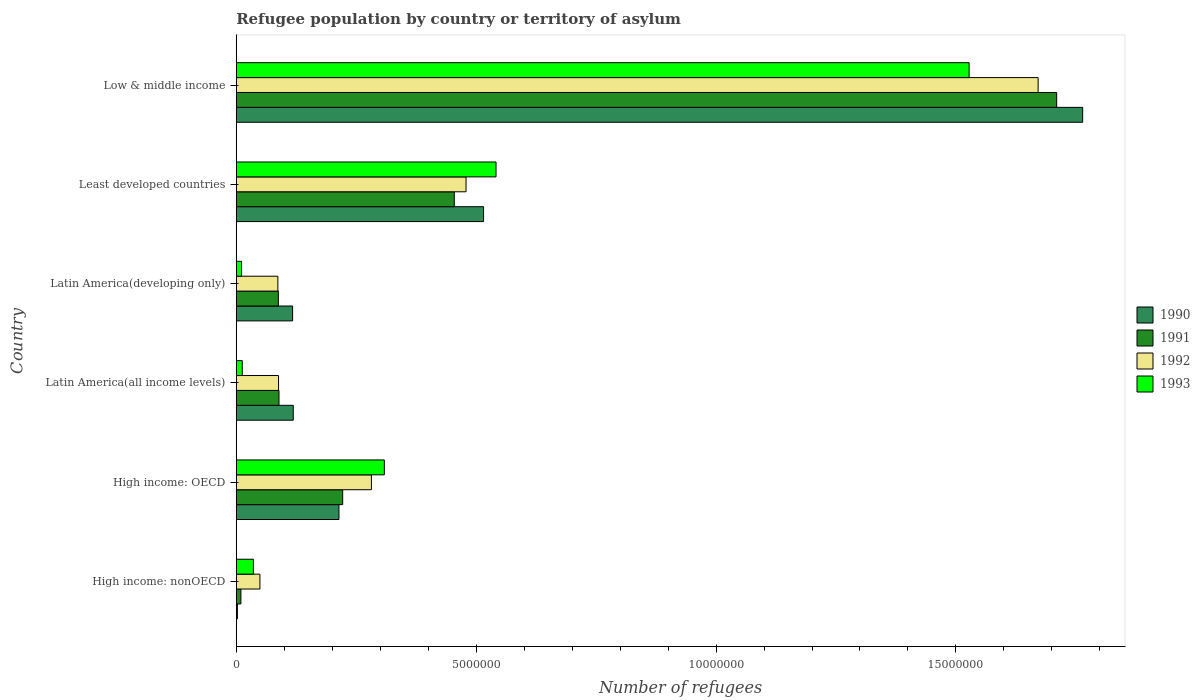Are the number of bars per tick equal to the number of legend labels?
Keep it short and to the point. Yes. Are the number of bars on each tick of the Y-axis equal?
Your answer should be compact. Yes. What is the label of the 3rd group of bars from the top?
Your response must be concise. Latin America(developing only). In how many cases, is the number of bars for a given country not equal to the number of legend labels?
Offer a very short reply. 0. What is the number of refugees in 1991 in High income: OECD?
Keep it short and to the point. 2.22e+06. Across all countries, what is the maximum number of refugees in 1993?
Your answer should be very brief. 1.53e+07. Across all countries, what is the minimum number of refugees in 1993?
Offer a very short reply. 1.11e+05. In which country was the number of refugees in 1992 minimum?
Provide a succinct answer. High income: nonOECD. What is the total number of refugees in 1993 in the graph?
Keep it short and to the point. 2.44e+07. What is the difference between the number of refugees in 1992 in High income: nonOECD and that in Latin America(developing only)?
Your answer should be compact. -3.74e+05. What is the difference between the number of refugees in 1993 in Least developed countries and the number of refugees in 1991 in High income: nonOECD?
Make the answer very short. 5.32e+06. What is the average number of refugees in 1990 per country?
Keep it short and to the point. 4.55e+06. What is the difference between the number of refugees in 1992 and number of refugees in 1991 in Least developed countries?
Your answer should be very brief. 2.45e+05. In how many countries, is the number of refugees in 1990 greater than 9000000 ?
Give a very brief answer. 1. What is the ratio of the number of refugees in 1990 in Latin America(all income levels) to that in Low & middle income?
Ensure brevity in your answer.  0.07. Is the number of refugees in 1991 in Latin America(all income levels) less than that in Latin America(developing only)?
Offer a terse response. No. What is the difference between the highest and the second highest number of refugees in 1990?
Make the answer very short. 1.25e+07. What is the difference between the highest and the lowest number of refugees in 1993?
Offer a very short reply. 1.52e+07. Is the sum of the number of refugees in 1992 in Latin America(all income levels) and Latin America(developing only) greater than the maximum number of refugees in 1993 across all countries?
Provide a short and direct response. No. What does the 1st bar from the top in High income: OECD represents?
Give a very brief answer. 1993. What does the 3rd bar from the bottom in High income: nonOECD represents?
Provide a succinct answer. 1992. Are all the bars in the graph horizontal?
Provide a succinct answer. Yes. How many countries are there in the graph?
Ensure brevity in your answer.  6. What is the difference between two consecutive major ticks on the X-axis?
Ensure brevity in your answer.  5.00e+06. Are the values on the major ticks of X-axis written in scientific E-notation?
Keep it short and to the point. No. Where does the legend appear in the graph?
Keep it short and to the point. Center right. What is the title of the graph?
Give a very brief answer. Refugee population by country or territory of asylum. Does "1980" appear as one of the legend labels in the graph?
Offer a very short reply. No. What is the label or title of the X-axis?
Provide a short and direct response. Number of refugees. What is the Number of refugees of 1990 in High income: nonOECD?
Your answer should be very brief. 2.39e+04. What is the Number of refugees of 1991 in High income: nonOECD?
Your answer should be very brief. 9.69e+04. What is the Number of refugees in 1992 in High income: nonOECD?
Your answer should be very brief. 4.93e+05. What is the Number of refugees in 1993 in High income: nonOECD?
Your response must be concise. 3.58e+05. What is the Number of refugees of 1990 in High income: OECD?
Your response must be concise. 2.14e+06. What is the Number of refugees in 1991 in High income: OECD?
Offer a terse response. 2.22e+06. What is the Number of refugees in 1992 in High income: OECD?
Offer a terse response. 2.82e+06. What is the Number of refugees of 1993 in High income: OECD?
Keep it short and to the point. 3.09e+06. What is the Number of refugees of 1990 in Latin America(all income levels)?
Offer a terse response. 1.19e+06. What is the Number of refugees in 1991 in Latin America(all income levels)?
Your response must be concise. 8.91e+05. What is the Number of refugees in 1992 in Latin America(all income levels)?
Give a very brief answer. 8.82e+05. What is the Number of refugees in 1993 in Latin America(all income levels)?
Provide a succinct answer. 1.25e+05. What is the Number of refugees of 1990 in Latin America(developing only)?
Make the answer very short. 1.17e+06. What is the Number of refugees in 1991 in Latin America(developing only)?
Provide a short and direct response. 8.78e+05. What is the Number of refugees of 1992 in Latin America(developing only)?
Your answer should be compact. 8.67e+05. What is the Number of refugees of 1993 in Latin America(developing only)?
Offer a terse response. 1.11e+05. What is the Number of refugees in 1990 in Least developed countries?
Your answer should be very brief. 5.15e+06. What is the Number of refugees in 1991 in Least developed countries?
Make the answer very short. 4.54e+06. What is the Number of refugees in 1992 in Least developed countries?
Give a very brief answer. 4.79e+06. What is the Number of refugees in 1993 in Least developed countries?
Give a very brief answer. 5.41e+06. What is the Number of refugees of 1990 in Low & middle income?
Provide a succinct answer. 1.76e+07. What is the Number of refugees of 1991 in Low & middle income?
Keep it short and to the point. 1.71e+07. What is the Number of refugees of 1992 in Low & middle income?
Your response must be concise. 1.67e+07. What is the Number of refugees in 1993 in Low & middle income?
Offer a terse response. 1.53e+07. Across all countries, what is the maximum Number of refugees in 1990?
Ensure brevity in your answer.  1.76e+07. Across all countries, what is the maximum Number of refugees of 1991?
Provide a succinct answer. 1.71e+07. Across all countries, what is the maximum Number of refugees in 1992?
Provide a short and direct response. 1.67e+07. Across all countries, what is the maximum Number of refugees in 1993?
Provide a short and direct response. 1.53e+07. Across all countries, what is the minimum Number of refugees in 1990?
Provide a short and direct response. 2.39e+04. Across all countries, what is the minimum Number of refugees of 1991?
Give a very brief answer. 9.69e+04. Across all countries, what is the minimum Number of refugees of 1992?
Provide a succinct answer. 4.93e+05. Across all countries, what is the minimum Number of refugees of 1993?
Provide a succinct answer. 1.11e+05. What is the total Number of refugees in 1990 in the graph?
Provide a short and direct response. 2.73e+07. What is the total Number of refugees in 1991 in the graph?
Offer a terse response. 2.57e+07. What is the total Number of refugees of 1992 in the graph?
Your answer should be compact. 2.66e+07. What is the total Number of refugees of 1993 in the graph?
Offer a terse response. 2.44e+07. What is the difference between the Number of refugees of 1990 in High income: nonOECD and that in High income: OECD?
Keep it short and to the point. -2.12e+06. What is the difference between the Number of refugees of 1991 in High income: nonOECD and that in High income: OECD?
Your response must be concise. -2.12e+06. What is the difference between the Number of refugees in 1992 in High income: nonOECD and that in High income: OECD?
Provide a succinct answer. -2.32e+06. What is the difference between the Number of refugees in 1993 in High income: nonOECD and that in High income: OECD?
Offer a terse response. -2.73e+06. What is the difference between the Number of refugees of 1990 in High income: nonOECD and that in Latin America(all income levels)?
Offer a very short reply. -1.16e+06. What is the difference between the Number of refugees of 1991 in High income: nonOECD and that in Latin America(all income levels)?
Ensure brevity in your answer.  -7.94e+05. What is the difference between the Number of refugees of 1992 in High income: nonOECD and that in Latin America(all income levels)?
Offer a very short reply. -3.88e+05. What is the difference between the Number of refugees of 1993 in High income: nonOECD and that in Latin America(all income levels)?
Your answer should be very brief. 2.33e+05. What is the difference between the Number of refugees in 1990 in High income: nonOECD and that in Latin America(developing only)?
Your response must be concise. -1.15e+06. What is the difference between the Number of refugees in 1991 in High income: nonOECD and that in Latin America(developing only)?
Keep it short and to the point. -7.81e+05. What is the difference between the Number of refugees of 1992 in High income: nonOECD and that in Latin America(developing only)?
Give a very brief answer. -3.74e+05. What is the difference between the Number of refugees in 1993 in High income: nonOECD and that in Latin America(developing only)?
Offer a terse response. 2.47e+05. What is the difference between the Number of refugees in 1990 in High income: nonOECD and that in Least developed countries?
Offer a terse response. -5.13e+06. What is the difference between the Number of refugees of 1991 in High income: nonOECD and that in Least developed countries?
Your response must be concise. -4.45e+06. What is the difference between the Number of refugees of 1992 in High income: nonOECD and that in Least developed countries?
Ensure brevity in your answer.  -4.30e+06. What is the difference between the Number of refugees of 1993 in High income: nonOECD and that in Least developed countries?
Your answer should be very brief. -5.06e+06. What is the difference between the Number of refugees in 1990 in High income: nonOECD and that in Low & middle income?
Ensure brevity in your answer.  -1.76e+07. What is the difference between the Number of refugees of 1991 in High income: nonOECD and that in Low & middle income?
Your answer should be compact. -1.70e+07. What is the difference between the Number of refugees in 1992 in High income: nonOECD and that in Low & middle income?
Provide a short and direct response. -1.62e+07. What is the difference between the Number of refugees of 1993 in High income: nonOECD and that in Low & middle income?
Offer a very short reply. -1.49e+07. What is the difference between the Number of refugees in 1990 in High income: OECD and that in Latin America(all income levels)?
Provide a short and direct response. 9.52e+05. What is the difference between the Number of refugees in 1991 in High income: OECD and that in Latin America(all income levels)?
Give a very brief answer. 1.33e+06. What is the difference between the Number of refugees of 1992 in High income: OECD and that in Latin America(all income levels)?
Your answer should be very brief. 1.94e+06. What is the difference between the Number of refugees in 1993 in High income: OECD and that in Latin America(all income levels)?
Offer a terse response. 2.96e+06. What is the difference between the Number of refugees of 1990 in High income: OECD and that in Latin America(developing only)?
Provide a succinct answer. 9.66e+05. What is the difference between the Number of refugees of 1991 in High income: OECD and that in Latin America(developing only)?
Give a very brief answer. 1.34e+06. What is the difference between the Number of refugees in 1992 in High income: OECD and that in Latin America(developing only)?
Offer a terse response. 1.95e+06. What is the difference between the Number of refugees of 1993 in High income: OECD and that in Latin America(developing only)?
Provide a short and direct response. 2.98e+06. What is the difference between the Number of refugees in 1990 in High income: OECD and that in Least developed countries?
Your response must be concise. -3.01e+06. What is the difference between the Number of refugees in 1991 in High income: OECD and that in Least developed countries?
Make the answer very short. -2.33e+06. What is the difference between the Number of refugees in 1992 in High income: OECD and that in Least developed countries?
Your response must be concise. -1.97e+06. What is the difference between the Number of refugees in 1993 in High income: OECD and that in Least developed countries?
Provide a short and direct response. -2.33e+06. What is the difference between the Number of refugees in 1990 in High income: OECD and that in Low & middle income?
Offer a very short reply. -1.55e+07. What is the difference between the Number of refugees of 1991 in High income: OECD and that in Low & middle income?
Ensure brevity in your answer.  -1.49e+07. What is the difference between the Number of refugees of 1992 in High income: OECD and that in Low & middle income?
Provide a succinct answer. -1.39e+07. What is the difference between the Number of refugees in 1993 in High income: OECD and that in Low & middle income?
Ensure brevity in your answer.  -1.22e+07. What is the difference between the Number of refugees in 1990 in Latin America(all income levels) and that in Latin America(developing only)?
Your answer should be very brief. 1.36e+04. What is the difference between the Number of refugees of 1991 in Latin America(all income levels) and that in Latin America(developing only)?
Give a very brief answer. 1.34e+04. What is the difference between the Number of refugees of 1992 in Latin America(all income levels) and that in Latin America(developing only)?
Provide a succinct answer. 1.41e+04. What is the difference between the Number of refugees in 1993 in Latin America(all income levels) and that in Latin America(developing only)?
Provide a short and direct response. 1.43e+04. What is the difference between the Number of refugees in 1990 in Latin America(all income levels) and that in Least developed countries?
Offer a very short reply. -3.97e+06. What is the difference between the Number of refugees of 1991 in Latin America(all income levels) and that in Least developed countries?
Provide a short and direct response. -3.65e+06. What is the difference between the Number of refugees in 1992 in Latin America(all income levels) and that in Least developed countries?
Make the answer very short. -3.91e+06. What is the difference between the Number of refugees of 1993 in Latin America(all income levels) and that in Least developed countries?
Provide a succinct answer. -5.29e+06. What is the difference between the Number of refugees in 1990 in Latin America(all income levels) and that in Low & middle income?
Provide a short and direct response. -1.65e+07. What is the difference between the Number of refugees in 1991 in Latin America(all income levels) and that in Low & middle income?
Provide a succinct answer. -1.62e+07. What is the difference between the Number of refugees in 1992 in Latin America(all income levels) and that in Low & middle income?
Provide a short and direct response. -1.58e+07. What is the difference between the Number of refugees of 1993 in Latin America(all income levels) and that in Low & middle income?
Offer a terse response. -1.51e+07. What is the difference between the Number of refugees in 1990 in Latin America(developing only) and that in Least developed countries?
Make the answer very short. -3.98e+06. What is the difference between the Number of refugees of 1991 in Latin America(developing only) and that in Least developed countries?
Ensure brevity in your answer.  -3.67e+06. What is the difference between the Number of refugees of 1992 in Latin America(developing only) and that in Least developed countries?
Provide a succinct answer. -3.92e+06. What is the difference between the Number of refugees in 1993 in Latin America(developing only) and that in Least developed countries?
Your response must be concise. -5.30e+06. What is the difference between the Number of refugees in 1990 in Latin America(developing only) and that in Low & middle income?
Your answer should be very brief. -1.65e+07. What is the difference between the Number of refugees of 1991 in Latin America(developing only) and that in Low & middle income?
Your response must be concise. -1.62e+07. What is the difference between the Number of refugees of 1992 in Latin America(developing only) and that in Low & middle income?
Your response must be concise. -1.58e+07. What is the difference between the Number of refugees in 1993 in Latin America(developing only) and that in Low & middle income?
Offer a very short reply. -1.52e+07. What is the difference between the Number of refugees in 1990 in Least developed countries and that in Low & middle income?
Your answer should be very brief. -1.25e+07. What is the difference between the Number of refugees of 1991 in Least developed countries and that in Low & middle income?
Ensure brevity in your answer.  -1.26e+07. What is the difference between the Number of refugees of 1992 in Least developed countries and that in Low & middle income?
Your answer should be very brief. -1.19e+07. What is the difference between the Number of refugees in 1993 in Least developed countries and that in Low & middle income?
Provide a succinct answer. -9.86e+06. What is the difference between the Number of refugees in 1990 in High income: nonOECD and the Number of refugees in 1991 in High income: OECD?
Your response must be concise. -2.19e+06. What is the difference between the Number of refugees of 1990 in High income: nonOECD and the Number of refugees of 1992 in High income: OECD?
Provide a short and direct response. -2.79e+06. What is the difference between the Number of refugees in 1990 in High income: nonOECD and the Number of refugees in 1993 in High income: OECD?
Provide a succinct answer. -3.06e+06. What is the difference between the Number of refugees in 1991 in High income: nonOECD and the Number of refugees in 1992 in High income: OECD?
Give a very brief answer. -2.72e+06. What is the difference between the Number of refugees in 1991 in High income: nonOECD and the Number of refugees in 1993 in High income: OECD?
Ensure brevity in your answer.  -2.99e+06. What is the difference between the Number of refugees in 1992 in High income: nonOECD and the Number of refugees in 1993 in High income: OECD?
Your answer should be very brief. -2.59e+06. What is the difference between the Number of refugees of 1990 in High income: nonOECD and the Number of refugees of 1991 in Latin America(all income levels)?
Provide a succinct answer. -8.67e+05. What is the difference between the Number of refugees in 1990 in High income: nonOECD and the Number of refugees in 1992 in Latin America(all income levels)?
Offer a very short reply. -8.58e+05. What is the difference between the Number of refugees of 1990 in High income: nonOECD and the Number of refugees of 1993 in Latin America(all income levels)?
Make the answer very short. -1.01e+05. What is the difference between the Number of refugees of 1991 in High income: nonOECD and the Number of refugees of 1992 in Latin America(all income levels)?
Provide a short and direct response. -7.85e+05. What is the difference between the Number of refugees of 1991 in High income: nonOECD and the Number of refugees of 1993 in Latin America(all income levels)?
Provide a succinct answer. -2.83e+04. What is the difference between the Number of refugees of 1992 in High income: nonOECD and the Number of refugees of 1993 in Latin America(all income levels)?
Offer a terse response. 3.68e+05. What is the difference between the Number of refugees in 1990 in High income: nonOECD and the Number of refugees in 1991 in Latin America(developing only)?
Make the answer very short. -8.54e+05. What is the difference between the Number of refugees of 1990 in High income: nonOECD and the Number of refugees of 1992 in Latin America(developing only)?
Your answer should be very brief. -8.44e+05. What is the difference between the Number of refugees in 1990 in High income: nonOECD and the Number of refugees in 1993 in Latin America(developing only)?
Offer a very short reply. -8.71e+04. What is the difference between the Number of refugees in 1991 in High income: nonOECD and the Number of refugees in 1992 in Latin America(developing only)?
Keep it short and to the point. -7.70e+05. What is the difference between the Number of refugees in 1991 in High income: nonOECD and the Number of refugees in 1993 in Latin America(developing only)?
Your answer should be compact. -1.41e+04. What is the difference between the Number of refugees in 1992 in High income: nonOECD and the Number of refugees in 1993 in Latin America(developing only)?
Give a very brief answer. 3.82e+05. What is the difference between the Number of refugees of 1990 in High income: nonOECD and the Number of refugees of 1991 in Least developed countries?
Offer a very short reply. -4.52e+06. What is the difference between the Number of refugees of 1990 in High income: nonOECD and the Number of refugees of 1992 in Least developed countries?
Your response must be concise. -4.77e+06. What is the difference between the Number of refugees of 1990 in High income: nonOECD and the Number of refugees of 1993 in Least developed countries?
Your answer should be very brief. -5.39e+06. What is the difference between the Number of refugees of 1991 in High income: nonOECD and the Number of refugees of 1992 in Least developed countries?
Give a very brief answer. -4.69e+06. What is the difference between the Number of refugees of 1991 in High income: nonOECD and the Number of refugees of 1993 in Least developed countries?
Offer a very short reply. -5.32e+06. What is the difference between the Number of refugees in 1992 in High income: nonOECD and the Number of refugees in 1993 in Least developed countries?
Give a very brief answer. -4.92e+06. What is the difference between the Number of refugees of 1990 in High income: nonOECD and the Number of refugees of 1991 in Low & middle income?
Provide a succinct answer. -1.71e+07. What is the difference between the Number of refugees of 1990 in High income: nonOECD and the Number of refugees of 1992 in Low & middle income?
Provide a succinct answer. -1.67e+07. What is the difference between the Number of refugees in 1990 in High income: nonOECD and the Number of refugees in 1993 in Low & middle income?
Ensure brevity in your answer.  -1.53e+07. What is the difference between the Number of refugees in 1991 in High income: nonOECD and the Number of refugees in 1992 in Low & middle income?
Your response must be concise. -1.66e+07. What is the difference between the Number of refugees of 1991 in High income: nonOECD and the Number of refugees of 1993 in Low & middle income?
Your answer should be very brief. -1.52e+07. What is the difference between the Number of refugees of 1992 in High income: nonOECD and the Number of refugees of 1993 in Low & middle income?
Give a very brief answer. -1.48e+07. What is the difference between the Number of refugees of 1990 in High income: OECD and the Number of refugees of 1991 in Latin America(all income levels)?
Ensure brevity in your answer.  1.25e+06. What is the difference between the Number of refugees in 1990 in High income: OECD and the Number of refugees in 1992 in Latin America(all income levels)?
Provide a short and direct response. 1.26e+06. What is the difference between the Number of refugees in 1990 in High income: OECD and the Number of refugees in 1993 in Latin America(all income levels)?
Your response must be concise. 2.02e+06. What is the difference between the Number of refugees of 1991 in High income: OECD and the Number of refugees of 1992 in Latin America(all income levels)?
Your answer should be very brief. 1.34e+06. What is the difference between the Number of refugees of 1991 in High income: OECD and the Number of refugees of 1993 in Latin America(all income levels)?
Your answer should be compact. 2.09e+06. What is the difference between the Number of refugees in 1992 in High income: OECD and the Number of refugees in 1993 in Latin America(all income levels)?
Ensure brevity in your answer.  2.69e+06. What is the difference between the Number of refugees in 1990 in High income: OECD and the Number of refugees in 1991 in Latin America(developing only)?
Offer a very short reply. 1.26e+06. What is the difference between the Number of refugees in 1990 in High income: OECD and the Number of refugees in 1992 in Latin America(developing only)?
Ensure brevity in your answer.  1.27e+06. What is the difference between the Number of refugees in 1990 in High income: OECD and the Number of refugees in 1993 in Latin America(developing only)?
Ensure brevity in your answer.  2.03e+06. What is the difference between the Number of refugees of 1991 in High income: OECD and the Number of refugees of 1992 in Latin America(developing only)?
Provide a short and direct response. 1.35e+06. What is the difference between the Number of refugees in 1991 in High income: OECD and the Number of refugees in 1993 in Latin America(developing only)?
Offer a terse response. 2.11e+06. What is the difference between the Number of refugees of 1992 in High income: OECD and the Number of refugees of 1993 in Latin America(developing only)?
Provide a short and direct response. 2.71e+06. What is the difference between the Number of refugees of 1990 in High income: OECD and the Number of refugees of 1991 in Least developed countries?
Offer a terse response. -2.40e+06. What is the difference between the Number of refugees of 1990 in High income: OECD and the Number of refugees of 1992 in Least developed countries?
Provide a short and direct response. -2.65e+06. What is the difference between the Number of refugees of 1990 in High income: OECD and the Number of refugees of 1993 in Least developed countries?
Your response must be concise. -3.27e+06. What is the difference between the Number of refugees of 1991 in High income: OECD and the Number of refugees of 1992 in Least developed countries?
Give a very brief answer. -2.57e+06. What is the difference between the Number of refugees of 1991 in High income: OECD and the Number of refugees of 1993 in Least developed countries?
Give a very brief answer. -3.20e+06. What is the difference between the Number of refugees in 1992 in High income: OECD and the Number of refugees in 1993 in Least developed countries?
Offer a very short reply. -2.60e+06. What is the difference between the Number of refugees of 1990 in High income: OECD and the Number of refugees of 1991 in Low & middle income?
Make the answer very short. -1.50e+07. What is the difference between the Number of refugees of 1990 in High income: OECD and the Number of refugees of 1992 in Low & middle income?
Offer a very short reply. -1.46e+07. What is the difference between the Number of refugees of 1990 in High income: OECD and the Number of refugees of 1993 in Low & middle income?
Offer a very short reply. -1.31e+07. What is the difference between the Number of refugees of 1991 in High income: OECD and the Number of refugees of 1992 in Low & middle income?
Provide a short and direct response. -1.45e+07. What is the difference between the Number of refugees of 1991 in High income: OECD and the Number of refugees of 1993 in Low & middle income?
Keep it short and to the point. -1.31e+07. What is the difference between the Number of refugees of 1992 in High income: OECD and the Number of refugees of 1993 in Low & middle income?
Provide a short and direct response. -1.25e+07. What is the difference between the Number of refugees in 1990 in Latin America(all income levels) and the Number of refugees in 1991 in Latin America(developing only)?
Ensure brevity in your answer.  3.11e+05. What is the difference between the Number of refugees in 1990 in Latin America(all income levels) and the Number of refugees in 1992 in Latin America(developing only)?
Ensure brevity in your answer.  3.21e+05. What is the difference between the Number of refugees of 1990 in Latin America(all income levels) and the Number of refugees of 1993 in Latin America(developing only)?
Offer a terse response. 1.08e+06. What is the difference between the Number of refugees of 1991 in Latin America(all income levels) and the Number of refugees of 1992 in Latin America(developing only)?
Provide a succinct answer. 2.35e+04. What is the difference between the Number of refugees in 1991 in Latin America(all income levels) and the Number of refugees in 1993 in Latin America(developing only)?
Provide a short and direct response. 7.80e+05. What is the difference between the Number of refugees of 1992 in Latin America(all income levels) and the Number of refugees of 1993 in Latin America(developing only)?
Provide a succinct answer. 7.71e+05. What is the difference between the Number of refugees in 1990 in Latin America(all income levels) and the Number of refugees in 1991 in Least developed countries?
Make the answer very short. -3.36e+06. What is the difference between the Number of refugees in 1990 in Latin America(all income levels) and the Number of refugees in 1992 in Least developed countries?
Ensure brevity in your answer.  -3.60e+06. What is the difference between the Number of refugees in 1990 in Latin America(all income levels) and the Number of refugees in 1993 in Least developed countries?
Offer a very short reply. -4.23e+06. What is the difference between the Number of refugees in 1991 in Latin America(all income levels) and the Number of refugees in 1992 in Least developed countries?
Make the answer very short. -3.90e+06. What is the difference between the Number of refugees in 1991 in Latin America(all income levels) and the Number of refugees in 1993 in Least developed countries?
Your response must be concise. -4.52e+06. What is the difference between the Number of refugees in 1992 in Latin America(all income levels) and the Number of refugees in 1993 in Least developed countries?
Your answer should be compact. -4.53e+06. What is the difference between the Number of refugees of 1990 in Latin America(all income levels) and the Number of refugees of 1991 in Low & middle income?
Your answer should be compact. -1.59e+07. What is the difference between the Number of refugees in 1990 in Latin America(all income levels) and the Number of refugees in 1992 in Low & middle income?
Ensure brevity in your answer.  -1.55e+07. What is the difference between the Number of refugees in 1990 in Latin America(all income levels) and the Number of refugees in 1993 in Low & middle income?
Give a very brief answer. -1.41e+07. What is the difference between the Number of refugees in 1991 in Latin America(all income levels) and the Number of refugees in 1992 in Low & middle income?
Your response must be concise. -1.58e+07. What is the difference between the Number of refugees of 1991 in Latin America(all income levels) and the Number of refugees of 1993 in Low & middle income?
Give a very brief answer. -1.44e+07. What is the difference between the Number of refugees of 1992 in Latin America(all income levels) and the Number of refugees of 1993 in Low & middle income?
Your answer should be compact. -1.44e+07. What is the difference between the Number of refugees of 1990 in Latin America(developing only) and the Number of refugees of 1991 in Least developed countries?
Offer a terse response. -3.37e+06. What is the difference between the Number of refugees in 1990 in Latin America(developing only) and the Number of refugees in 1992 in Least developed countries?
Provide a succinct answer. -3.61e+06. What is the difference between the Number of refugees of 1990 in Latin America(developing only) and the Number of refugees of 1993 in Least developed countries?
Offer a terse response. -4.24e+06. What is the difference between the Number of refugees in 1991 in Latin America(developing only) and the Number of refugees in 1992 in Least developed countries?
Your answer should be compact. -3.91e+06. What is the difference between the Number of refugees in 1991 in Latin America(developing only) and the Number of refugees in 1993 in Least developed countries?
Your answer should be compact. -4.54e+06. What is the difference between the Number of refugees in 1992 in Latin America(developing only) and the Number of refugees in 1993 in Least developed countries?
Ensure brevity in your answer.  -4.55e+06. What is the difference between the Number of refugees of 1990 in Latin America(developing only) and the Number of refugees of 1991 in Low & middle income?
Provide a succinct answer. -1.59e+07. What is the difference between the Number of refugees of 1990 in Latin America(developing only) and the Number of refugees of 1992 in Low & middle income?
Make the answer very short. -1.55e+07. What is the difference between the Number of refugees of 1990 in Latin America(developing only) and the Number of refugees of 1993 in Low & middle income?
Ensure brevity in your answer.  -1.41e+07. What is the difference between the Number of refugees of 1991 in Latin America(developing only) and the Number of refugees of 1992 in Low & middle income?
Provide a short and direct response. -1.58e+07. What is the difference between the Number of refugees in 1991 in Latin America(developing only) and the Number of refugees in 1993 in Low & middle income?
Provide a short and direct response. -1.44e+07. What is the difference between the Number of refugees in 1992 in Latin America(developing only) and the Number of refugees in 1993 in Low & middle income?
Offer a terse response. -1.44e+07. What is the difference between the Number of refugees in 1990 in Least developed countries and the Number of refugees in 1991 in Low & middle income?
Ensure brevity in your answer.  -1.19e+07. What is the difference between the Number of refugees of 1990 in Least developed countries and the Number of refugees of 1992 in Low & middle income?
Make the answer very short. -1.16e+07. What is the difference between the Number of refugees in 1990 in Least developed countries and the Number of refugees in 1993 in Low & middle income?
Your answer should be very brief. -1.01e+07. What is the difference between the Number of refugees of 1991 in Least developed countries and the Number of refugees of 1992 in Low & middle income?
Provide a short and direct response. -1.22e+07. What is the difference between the Number of refugees of 1991 in Least developed countries and the Number of refugees of 1993 in Low & middle income?
Provide a short and direct response. -1.07e+07. What is the difference between the Number of refugees in 1992 in Least developed countries and the Number of refugees in 1993 in Low & middle income?
Keep it short and to the point. -1.05e+07. What is the average Number of refugees in 1990 per country?
Your response must be concise. 4.55e+06. What is the average Number of refugees in 1991 per country?
Offer a terse response. 4.29e+06. What is the average Number of refugees of 1992 per country?
Your answer should be very brief. 4.43e+06. What is the average Number of refugees in 1993 per country?
Your answer should be compact. 4.06e+06. What is the difference between the Number of refugees in 1990 and Number of refugees in 1991 in High income: nonOECD?
Give a very brief answer. -7.30e+04. What is the difference between the Number of refugees of 1990 and Number of refugees of 1992 in High income: nonOECD?
Keep it short and to the point. -4.69e+05. What is the difference between the Number of refugees of 1990 and Number of refugees of 1993 in High income: nonOECD?
Offer a terse response. -3.34e+05. What is the difference between the Number of refugees in 1991 and Number of refugees in 1992 in High income: nonOECD?
Give a very brief answer. -3.96e+05. What is the difference between the Number of refugees of 1991 and Number of refugees of 1993 in High income: nonOECD?
Offer a terse response. -2.61e+05. What is the difference between the Number of refugees of 1992 and Number of refugees of 1993 in High income: nonOECD?
Your answer should be compact. 1.35e+05. What is the difference between the Number of refugees of 1990 and Number of refugees of 1991 in High income: OECD?
Your answer should be compact. -7.80e+04. What is the difference between the Number of refugees in 1990 and Number of refugees in 1992 in High income: OECD?
Offer a terse response. -6.77e+05. What is the difference between the Number of refugees in 1990 and Number of refugees in 1993 in High income: OECD?
Your response must be concise. -9.46e+05. What is the difference between the Number of refugees in 1991 and Number of refugees in 1992 in High income: OECD?
Offer a very short reply. -5.99e+05. What is the difference between the Number of refugees in 1991 and Number of refugees in 1993 in High income: OECD?
Provide a succinct answer. -8.68e+05. What is the difference between the Number of refugees of 1992 and Number of refugees of 1993 in High income: OECD?
Make the answer very short. -2.69e+05. What is the difference between the Number of refugees of 1990 and Number of refugees of 1991 in Latin America(all income levels)?
Offer a terse response. 2.97e+05. What is the difference between the Number of refugees in 1990 and Number of refugees in 1992 in Latin America(all income levels)?
Provide a short and direct response. 3.07e+05. What is the difference between the Number of refugees of 1990 and Number of refugees of 1993 in Latin America(all income levels)?
Your answer should be very brief. 1.06e+06. What is the difference between the Number of refugees of 1991 and Number of refugees of 1992 in Latin America(all income levels)?
Provide a succinct answer. 9437. What is the difference between the Number of refugees of 1991 and Number of refugees of 1993 in Latin America(all income levels)?
Give a very brief answer. 7.66e+05. What is the difference between the Number of refugees in 1992 and Number of refugees in 1993 in Latin America(all income levels)?
Provide a short and direct response. 7.56e+05. What is the difference between the Number of refugees in 1990 and Number of refugees in 1991 in Latin America(developing only)?
Keep it short and to the point. 2.97e+05. What is the difference between the Number of refugees of 1990 and Number of refugees of 1992 in Latin America(developing only)?
Provide a succinct answer. 3.07e+05. What is the difference between the Number of refugees in 1990 and Number of refugees in 1993 in Latin America(developing only)?
Offer a terse response. 1.06e+06. What is the difference between the Number of refugees in 1991 and Number of refugees in 1992 in Latin America(developing only)?
Your answer should be very brief. 1.01e+04. What is the difference between the Number of refugees in 1991 and Number of refugees in 1993 in Latin America(developing only)?
Make the answer very short. 7.67e+05. What is the difference between the Number of refugees in 1992 and Number of refugees in 1993 in Latin America(developing only)?
Your answer should be compact. 7.56e+05. What is the difference between the Number of refugees in 1990 and Number of refugees in 1991 in Least developed countries?
Offer a terse response. 6.10e+05. What is the difference between the Number of refugees of 1990 and Number of refugees of 1992 in Least developed countries?
Provide a short and direct response. 3.65e+05. What is the difference between the Number of refugees in 1990 and Number of refugees in 1993 in Least developed countries?
Provide a succinct answer. -2.60e+05. What is the difference between the Number of refugees in 1991 and Number of refugees in 1992 in Least developed countries?
Offer a very short reply. -2.45e+05. What is the difference between the Number of refugees of 1991 and Number of refugees of 1993 in Least developed countries?
Keep it short and to the point. -8.70e+05. What is the difference between the Number of refugees in 1992 and Number of refugees in 1993 in Least developed countries?
Keep it short and to the point. -6.25e+05. What is the difference between the Number of refugees of 1990 and Number of refugees of 1991 in Low & middle income?
Offer a terse response. 5.42e+05. What is the difference between the Number of refugees in 1990 and Number of refugees in 1992 in Low & middle income?
Your answer should be compact. 9.28e+05. What is the difference between the Number of refugees of 1990 and Number of refugees of 1993 in Low & middle income?
Your response must be concise. 2.37e+06. What is the difference between the Number of refugees of 1991 and Number of refugees of 1992 in Low & middle income?
Your answer should be compact. 3.87e+05. What is the difference between the Number of refugees of 1991 and Number of refugees of 1993 in Low & middle income?
Make the answer very short. 1.82e+06. What is the difference between the Number of refugees in 1992 and Number of refugees in 1993 in Low & middle income?
Your response must be concise. 1.44e+06. What is the ratio of the Number of refugees in 1990 in High income: nonOECD to that in High income: OECD?
Ensure brevity in your answer.  0.01. What is the ratio of the Number of refugees in 1991 in High income: nonOECD to that in High income: OECD?
Provide a short and direct response. 0.04. What is the ratio of the Number of refugees in 1992 in High income: nonOECD to that in High income: OECD?
Ensure brevity in your answer.  0.18. What is the ratio of the Number of refugees in 1993 in High income: nonOECD to that in High income: OECD?
Provide a succinct answer. 0.12. What is the ratio of the Number of refugees of 1990 in High income: nonOECD to that in Latin America(all income levels)?
Provide a succinct answer. 0.02. What is the ratio of the Number of refugees in 1991 in High income: nonOECD to that in Latin America(all income levels)?
Your answer should be very brief. 0.11. What is the ratio of the Number of refugees of 1992 in High income: nonOECD to that in Latin America(all income levels)?
Give a very brief answer. 0.56. What is the ratio of the Number of refugees in 1993 in High income: nonOECD to that in Latin America(all income levels)?
Make the answer very short. 2.86. What is the ratio of the Number of refugees of 1990 in High income: nonOECD to that in Latin America(developing only)?
Keep it short and to the point. 0.02. What is the ratio of the Number of refugees in 1991 in High income: nonOECD to that in Latin America(developing only)?
Provide a succinct answer. 0.11. What is the ratio of the Number of refugees of 1992 in High income: nonOECD to that in Latin America(developing only)?
Provide a succinct answer. 0.57. What is the ratio of the Number of refugees in 1993 in High income: nonOECD to that in Latin America(developing only)?
Your response must be concise. 3.23. What is the ratio of the Number of refugees of 1990 in High income: nonOECD to that in Least developed countries?
Give a very brief answer. 0. What is the ratio of the Number of refugees in 1991 in High income: nonOECD to that in Least developed countries?
Offer a terse response. 0.02. What is the ratio of the Number of refugees in 1992 in High income: nonOECD to that in Least developed countries?
Give a very brief answer. 0.1. What is the ratio of the Number of refugees in 1993 in High income: nonOECD to that in Least developed countries?
Provide a succinct answer. 0.07. What is the ratio of the Number of refugees in 1990 in High income: nonOECD to that in Low & middle income?
Your answer should be very brief. 0. What is the ratio of the Number of refugees of 1991 in High income: nonOECD to that in Low & middle income?
Your answer should be very brief. 0.01. What is the ratio of the Number of refugees in 1992 in High income: nonOECD to that in Low & middle income?
Offer a very short reply. 0.03. What is the ratio of the Number of refugees in 1993 in High income: nonOECD to that in Low & middle income?
Keep it short and to the point. 0.02. What is the ratio of the Number of refugees of 1990 in High income: OECD to that in Latin America(all income levels)?
Your answer should be very brief. 1.8. What is the ratio of the Number of refugees in 1991 in High income: OECD to that in Latin America(all income levels)?
Give a very brief answer. 2.49. What is the ratio of the Number of refugees of 1992 in High income: OECD to that in Latin America(all income levels)?
Your answer should be very brief. 3.2. What is the ratio of the Number of refugees of 1993 in High income: OECD to that in Latin America(all income levels)?
Your answer should be very brief. 24.64. What is the ratio of the Number of refugees in 1990 in High income: OECD to that in Latin America(developing only)?
Give a very brief answer. 1.82. What is the ratio of the Number of refugees of 1991 in High income: OECD to that in Latin America(developing only)?
Your answer should be compact. 2.53. What is the ratio of the Number of refugees in 1992 in High income: OECD to that in Latin America(developing only)?
Make the answer very short. 3.25. What is the ratio of the Number of refugees of 1993 in High income: OECD to that in Latin America(developing only)?
Your answer should be very brief. 27.81. What is the ratio of the Number of refugees in 1990 in High income: OECD to that in Least developed countries?
Provide a succinct answer. 0.42. What is the ratio of the Number of refugees of 1991 in High income: OECD to that in Least developed countries?
Give a very brief answer. 0.49. What is the ratio of the Number of refugees in 1992 in High income: OECD to that in Least developed countries?
Provide a succinct answer. 0.59. What is the ratio of the Number of refugees of 1993 in High income: OECD to that in Least developed countries?
Your answer should be compact. 0.57. What is the ratio of the Number of refugees in 1990 in High income: OECD to that in Low & middle income?
Offer a very short reply. 0.12. What is the ratio of the Number of refugees in 1991 in High income: OECD to that in Low & middle income?
Your response must be concise. 0.13. What is the ratio of the Number of refugees in 1992 in High income: OECD to that in Low & middle income?
Give a very brief answer. 0.17. What is the ratio of the Number of refugees of 1993 in High income: OECD to that in Low & middle income?
Provide a short and direct response. 0.2. What is the ratio of the Number of refugees of 1990 in Latin America(all income levels) to that in Latin America(developing only)?
Provide a succinct answer. 1.01. What is the ratio of the Number of refugees of 1991 in Latin America(all income levels) to that in Latin America(developing only)?
Your answer should be compact. 1.02. What is the ratio of the Number of refugees of 1992 in Latin America(all income levels) to that in Latin America(developing only)?
Give a very brief answer. 1.02. What is the ratio of the Number of refugees in 1993 in Latin America(all income levels) to that in Latin America(developing only)?
Provide a short and direct response. 1.13. What is the ratio of the Number of refugees of 1990 in Latin America(all income levels) to that in Least developed countries?
Keep it short and to the point. 0.23. What is the ratio of the Number of refugees in 1991 in Latin America(all income levels) to that in Least developed countries?
Keep it short and to the point. 0.2. What is the ratio of the Number of refugees of 1992 in Latin America(all income levels) to that in Least developed countries?
Your response must be concise. 0.18. What is the ratio of the Number of refugees of 1993 in Latin America(all income levels) to that in Least developed countries?
Offer a terse response. 0.02. What is the ratio of the Number of refugees in 1990 in Latin America(all income levels) to that in Low & middle income?
Your answer should be compact. 0.07. What is the ratio of the Number of refugees in 1991 in Latin America(all income levels) to that in Low & middle income?
Your answer should be very brief. 0.05. What is the ratio of the Number of refugees in 1992 in Latin America(all income levels) to that in Low & middle income?
Your answer should be very brief. 0.05. What is the ratio of the Number of refugees of 1993 in Latin America(all income levels) to that in Low & middle income?
Offer a very short reply. 0.01. What is the ratio of the Number of refugees in 1990 in Latin America(developing only) to that in Least developed countries?
Your answer should be compact. 0.23. What is the ratio of the Number of refugees in 1991 in Latin America(developing only) to that in Least developed countries?
Give a very brief answer. 0.19. What is the ratio of the Number of refugees of 1992 in Latin America(developing only) to that in Least developed countries?
Keep it short and to the point. 0.18. What is the ratio of the Number of refugees of 1993 in Latin America(developing only) to that in Least developed countries?
Your response must be concise. 0.02. What is the ratio of the Number of refugees in 1990 in Latin America(developing only) to that in Low & middle income?
Ensure brevity in your answer.  0.07. What is the ratio of the Number of refugees of 1991 in Latin America(developing only) to that in Low & middle income?
Your answer should be compact. 0.05. What is the ratio of the Number of refugees of 1992 in Latin America(developing only) to that in Low & middle income?
Ensure brevity in your answer.  0.05. What is the ratio of the Number of refugees in 1993 in Latin America(developing only) to that in Low & middle income?
Offer a terse response. 0.01. What is the ratio of the Number of refugees of 1990 in Least developed countries to that in Low & middle income?
Make the answer very short. 0.29. What is the ratio of the Number of refugees of 1991 in Least developed countries to that in Low & middle income?
Keep it short and to the point. 0.27. What is the ratio of the Number of refugees of 1992 in Least developed countries to that in Low & middle income?
Provide a succinct answer. 0.29. What is the ratio of the Number of refugees in 1993 in Least developed countries to that in Low & middle income?
Ensure brevity in your answer.  0.35. What is the difference between the highest and the second highest Number of refugees in 1990?
Offer a terse response. 1.25e+07. What is the difference between the highest and the second highest Number of refugees of 1991?
Offer a very short reply. 1.26e+07. What is the difference between the highest and the second highest Number of refugees of 1992?
Your answer should be very brief. 1.19e+07. What is the difference between the highest and the second highest Number of refugees in 1993?
Your response must be concise. 9.86e+06. What is the difference between the highest and the lowest Number of refugees in 1990?
Offer a very short reply. 1.76e+07. What is the difference between the highest and the lowest Number of refugees of 1991?
Offer a very short reply. 1.70e+07. What is the difference between the highest and the lowest Number of refugees in 1992?
Provide a short and direct response. 1.62e+07. What is the difference between the highest and the lowest Number of refugees of 1993?
Keep it short and to the point. 1.52e+07. 